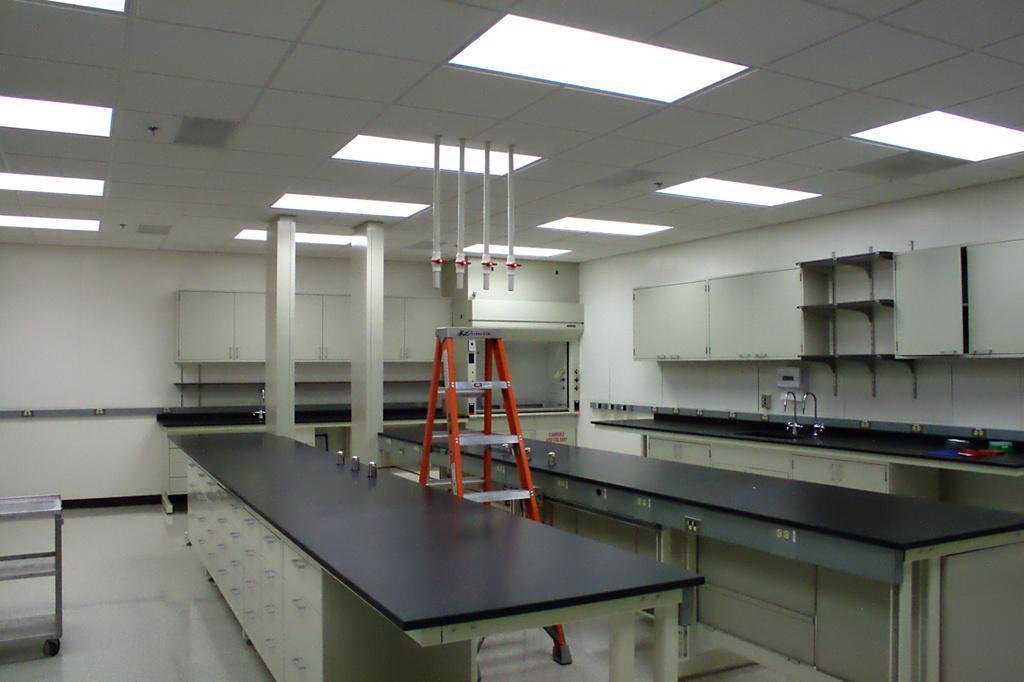Can you describe this image briefly? In this image, we can see cupboards, tables, ladder stand, taps, wall, few objects and floor. In the background, we can see pillars. Top of the image, we can see the ceiling, lights and pipes. 